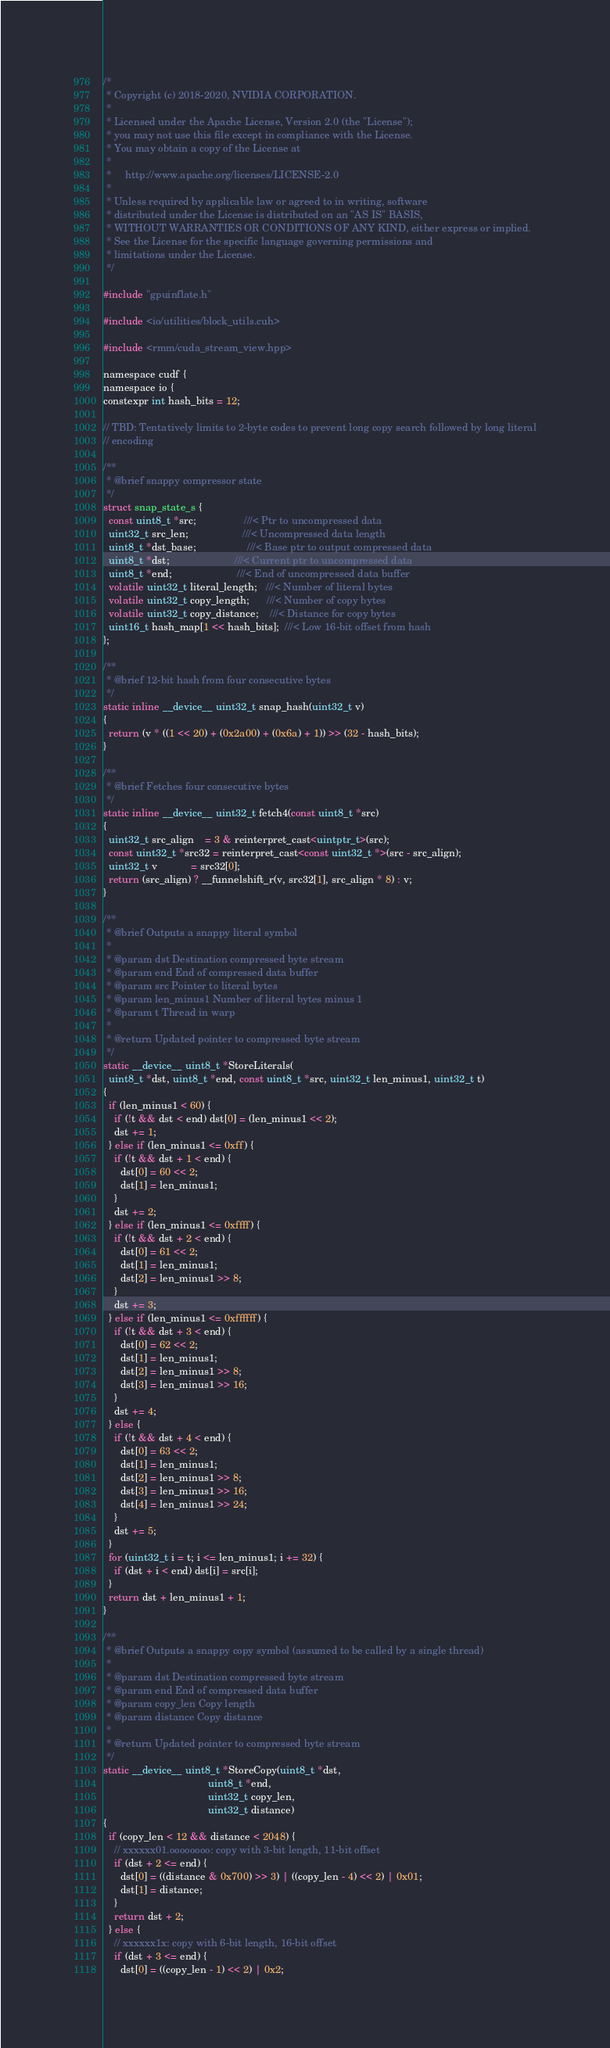Convert code to text. <code><loc_0><loc_0><loc_500><loc_500><_Cuda_>/*
 * Copyright (c) 2018-2020, NVIDIA CORPORATION.
 *
 * Licensed under the Apache License, Version 2.0 (the "License");
 * you may not use this file except in compliance with the License.
 * You may obtain a copy of the License at
 *
 *     http://www.apache.org/licenses/LICENSE-2.0
 *
 * Unless required by applicable law or agreed to in writing, software
 * distributed under the License is distributed on an "AS IS" BASIS,
 * WITHOUT WARRANTIES OR CONDITIONS OF ANY KIND, either express or implied.
 * See the License for the specific language governing permissions and
 * limitations under the License.
 */

#include "gpuinflate.h"

#include <io/utilities/block_utils.cuh>

#include <rmm/cuda_stream_view.hpp>

namespace cudf {
namespace io {
constexpr int hash_bits = 12;

// TBD: Tentatively limits to 2-byte codes to prevent long copy search followed by long literal
// encoding

/**
 * @brief snappy compressor state
 */
struct snap_state_s {
  const uint8_t *src;                 ///< Ptr to uncompressed data
  uint32_t src_len;                   ///< Uncompressed data length
  uint8_t *dst_base;                  ///< Base ptr to output compressed data
  uint8_t *dst;                       ///< Current ptr to uncompressed data
  uint8_t *end;                       ///< End of uncompressed data buffer
  volatile uint32_t literal_length;   ///< Number of literal bytes
  volatile uint32_t copy_length;      ///< Number of copy bytes
  volatile uint32_t copy_distance;    ///< Distance for copy bytes
  uint16_t hash_map[1 << hash_bits];  ///< Low 16-bit offset from hash
};

/**
 * @brief 12-bit hash from four consecutive bytes
 */
static inline __device__ uint32_t snap_hash(uint32_t v)
{
  return (v * ((1 << 20) + (0x2a00) + (0x6a) + 1)) >> (32 - hash_bits);
}

/**
 * @brief Fetches four consecutive bytes
 */
static inline __device__ uint32_t fetch4(const uint8_t *src)
{
  uint32_t src_align    = 3 & reinterpret_cast<uintptr_t>(src);
  const uint32_t *src32 = reinterpret_cast<const uint32_t *>(src - src_align);
  uint32_t v            = src32[0];
  return (src_align) ? __funnelshift_r(v, src32[1], src_align * 8) : v;
}

/**
 * @brief Outputs a snappy literal symbol
 *
 * @param dst Destination compressed byte stream
 * @param end End of compressed data buffer
 * @param src Pointer to literal bytes
 * @param len_minus1 Number of literal bytes minus 1
 * @param t Thread in warp
 *
 * @return Updated pointer to compressed byte stream
 */
static __device__ uint8_t *StoreLiterals(
  uint8_t *dst, uint8_t *end, const uint8_t *src, uint32_t len_minus1, uint32_t t)
{
  if (len_minus1 < 60) {
    if (!t && dst < end) dst[0] = (len_minus1 << 2);
    dst += 1;
  } else if (len_minus1 <= 0xff) {
    if (!t && dst + 1 < end) {
      dst[0] = 60 << 2;
      dst[1] = len_minus1;
    }
    dst += 2;
  } else if (len_minus1 <= 0xffff) {
    if (!t && dst + 2 < end) {
      dst[0] = 61 << 2;
      dst[1] = len_minus1;
      dst[2] = len_minus1 >> 8;
    }
    dst += 3;
  } else if (len_minus1 <= 0xffffff) {
    if (!t && dst + 3 < end) {
      dst[0] = 62 << 2;
      dst[1] = len_minus1;
      dst[2] = len_minus1 >> 8;
      dst[3] = len_minus1 >> 16;
    }
    dst += 4;
  } else {
    if (!t && dst + 4 < end) {
      dst[0] = 63 << 2;
      dst[1] = len_minus1;
      dst[2] = len_minus1 >> 8;
      dst[3] = len_minus1 >> 16;
      dst[4] = len_minus1 >> 24;
    }
    dst += 5;
  }
  for (uint32_t i = t; i <= len_minus1; i += 32) {
    if (dst + i < end) dst[i] = src[i];
  }
  return dst + len_minus1 + 1;
}

/**
 * @brief Outputs a snappy copy symbol (assumed to be called by a single thread)
 *
 * @param dst Destination compressed byte stream
 * @param end End of compressed data buffer
 * @param copy_len Copy length
 * @param distance Copy distance
 *
 * @return Updated pointer to compressed byte stream
 */
static __device__ uint8_t *StoreCopy(uint8_t *dst,
                                     uint8_t *end,
                                     uint32_t copy_len,
                                     uint32_t distance)
{
  if (copy_len < 12 && distance < 2048) {
    // xxxxxx01.oooooooo: copy with 3-bit length, 11-bit offset
    if (dst + 2 <= end) {
      dst[0] = ((distance & 0x700) >> 3) | ((copy_len - 4) << 2) | 0x01;
      dst[1] = distance;
    }
    return dst + 2;
  } else {
    // xxxxxx1x: copy with 6-bit length, 16-bit offset
    if (dst + 3 <= end) {
      dst[0] = ((copy_len - 1) << 2) | 0x2;</code> 